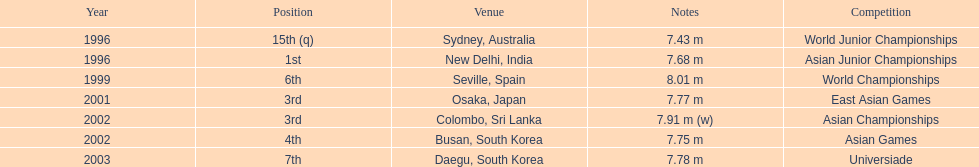Could you help me parse every detail presented in this table? {'header': ['Year', 'Position', 'Venue', 'Notes', 'Competition'], 'rows': [['1996', '15th (q)', 'Sydney, Australia', '7.43 m', 'World Junior Championships'], ['1996', '1st', 'New Delhi, India', '7.68 m', 'Asian Junior Championships'], ['1999', '6th', 'Seville, Spain', '8.01 m', 'World Championships'], ['2001', '3rd', 'Osaka, Japan', '7.77 m', 'East Asian Games'], ['2002', '3rd', 'Colombo, Sri Lanka', '7.91 m (w)', 'Asian Championships'], ['2002', '4th', 'Busan, South Korea', '7.75 m', 'Asian Games'], ['2003', '7th', 'Daegu, South Korea', '7.78 m', 'Universiade']]} How many total competitions were in south korea? 2. 